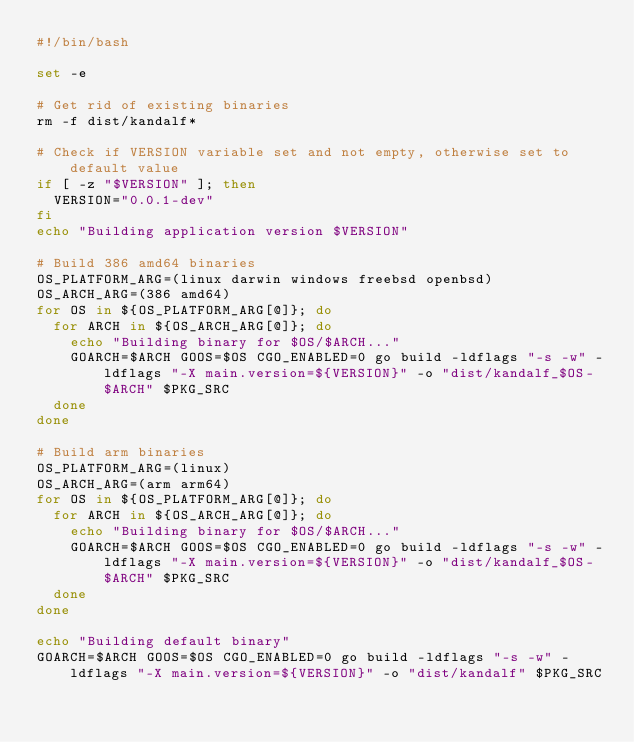<code> <loc_0><loc_0><loc_500><loc_500><_Bash_>#!/bin/bash

set -e

# Get rid of existing binaries
rm -f dist/kandalf*

# Check if VERSION variable set and not empty, otherwise set to default value
if [ -z "$VERSION" ]; then
  VERSION="0.0.1-dev"
fi
echo "Building application version $VERSION"

# Build 386 amd64 binaries
OS_PLATFORM_ARG=(linux darwin windows freebsd openbsd)
OS_ARCH_ARG=(386 amd64)
for OS in ${OS_PLATFORM_ARG[@]}; do
  for ARCH in ${OS_ARCH_ARG[@]}; do
    echo "Building binary for $OS/$ARCH..."
    GOARCH=$ARCH GOOS=$OS CGO_ENABLED=0 go build -ldflags "-s -w" -ldflags "-X main.version=${VERSION}" -o "dist/kandalf_$OS-$ARCH" $PKG_SRC
  done
done

# Build arm binaries
OS_PLATFORM_ARG=(linux)
OS_ARCH_ARG=(arm arm64)
for OS in ${OS_PLATFORM_ARG[@]}; do
  for ARCH in ${OS_ARCH_ARG[@]}; do
    echo "Building binary for $OS/$ARCH..."
    GOARCH=$ARCH GOOS=$OS CGO_ENABLED=0 go build -ldflags "-s -w" -ldflags "-X main.version=${VERSION}" -o "dist/kandalf_$OS-$ARCH" $PKG_SRC
  done
done

echo "Building default binary"
GOARCH=$ARCH GOOS=$OS CGO_ENABLED=0 go build -ldflags "-s -w" -ldflags "-X main.version=${VERSION}" -o "dist/kandalf" $PKG_SRC
</code> 